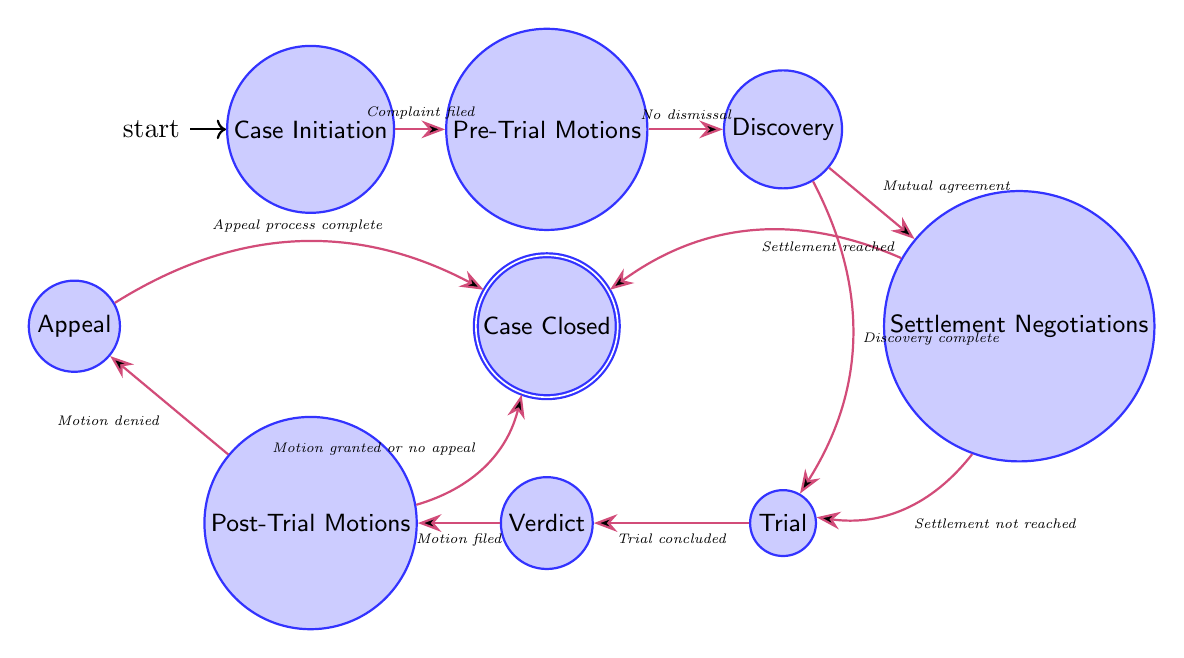What is the starting state of the case progression? The starting state is indicated by the initial node marked in the diagram, which is "Case Initiation."
Answer: Case Initiation How many states are in the diagram? By counting each distinct node that represents a state within the diagram, there are a total of 9 unique states present.
Answer: 9 What transition occurs after "Discovery"? The transition from "Discovery" can lead to either "Settlement Negotiations" or "Trial," based on the condition where a mutual agreement to negotiate or if the discovery is complete is established.
Answer: Settlement Negotiations or Trial What condition leads from "Settlement Negotiations" to "Case Closed"? The transition from "Settlement Negotiations" to "Case Closed" is contingent upon the condition of reaching a settlement.
Answer: Settlement reached Which state represents the conclusion of the case? The conclusion of the case is represented by the final state in the diagram, which is "Case Closed."
Answer: Case Closed Trace the path from "Pre-Trial Motions" to "Case Closed." What conditions are involved? Starting from "Pre-Trial Motions," the transition goes to "Discovery" if there is no dismissal. From "Discovery," it can proceed to "Settlement Negotiations" if there is mutual agreement, leading eventually to "Case Closed" if a settlement is reached. Each step requires fulfilling a condition.
Answer: No dismissal → Mutual agreement → Settlement reached What motion can lead to an appeal? The motion that can lead to an appeal is a "Post-Trial Motion" that gets denied, allowing the losing party to appeal the decision to a higher court.
Answer: Motion denied How does the case progress from "Trial" to "Verdict"? The transition from "Trial" to "Verdict" occurs after the trial is concluded, where the case is presented before a judge or jury for the verdict to be delivered.
Answer: Trial concluded What edge condition follows “Verdict”? After reaching the "Verdict" state, the case can move into "Post-Trial Motions" if a motion is filed in response to the verdict.
Answer: Motion filed What happens if the “Post-Trial Motion” is granted? If the "Post-Trial Motion" is granted or if there is no appeal, the state progresses directly to "Case Closed," terminating the case.
Answer: Case Closed 